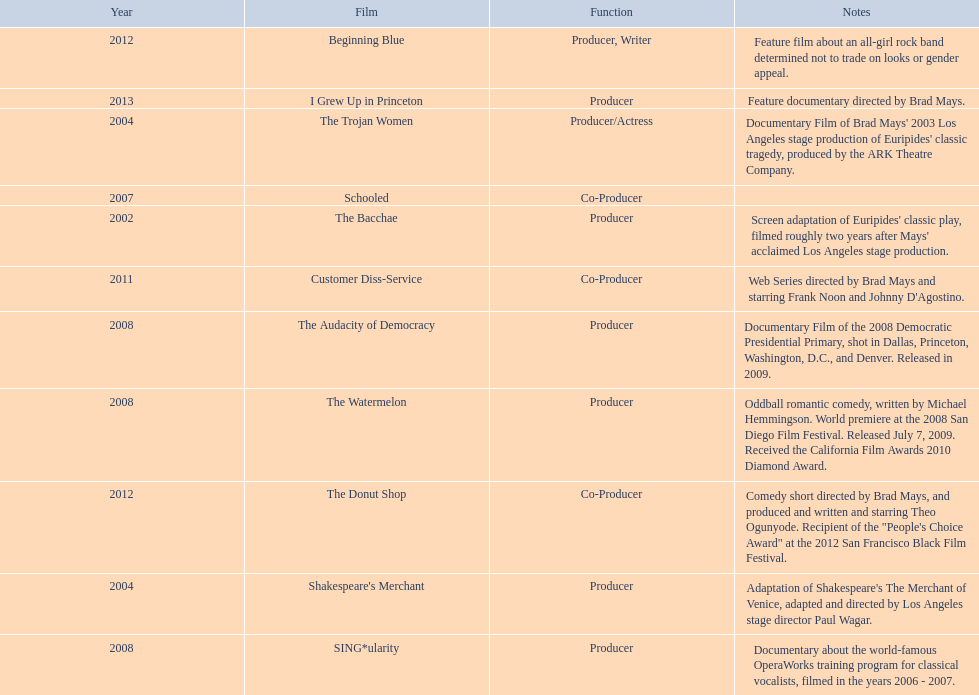Who was the first producer that made the film sing*ularity? Lorenda Starfelt. Can you parse all the data within this table? {'header': ['Year', 'Film', 'Function', 'Notes'], 'rows': [['2012', 'Beginning Blue', 'Producer, Writer', 'Feature film about an all-girl rock band determined not to trade on looks or gender appeal.'], ['2013', 'I Grew Up in Princeton', 'Producer', 'Feature documentary directed by Brad Mays.'], ['2004', 'The Trojan Women', 'Producer/Actress', "Documentary Film of Brad Mays' 2003 Los Angeles stage production of Euripides' classic tragedy, produced by the ARK Theatre Company."], ['2007', 'Schooled', 'Co-Producer', ''], ['2002', 'The Bacchae', 'Producer', "Screen adaptation of Euripides' classic play, filmed roughly two years after Mays' acclaimed Los Angeles stage production."], ['2011', 'Customer Diss-Service', 'Co-Producer', "Web Series directed by Brad Mays and starring Frank Noon and Johnny D'Agostino."], ['2008', 'The Audacity of Democracy', 'Producer', 'Documentary Film of the 2008 Democratic Presidential Primary, shot in Dallas, Princeton, Washington, D.C., and Denver. Released in 2009.'], ['2008', 'The Watermelon', 'Producer', 'Oddball romantic comedy, written by Michael Hemmingson. World premiere at the 2008 San Diego Film Festival. Released July 7, 2009. Received the California Film Awards 2010 Diamond Award.'], ['2012', 'The Donut Shop', 'Co-Producer', 'Comedy short directed by Brad Mays, and produced and written and starring Theo Ogunyode. Recipient of the "People\'s Choice Award" at the 2012 San Francisco Black Film Festival.'], ['2004', "Shakespeare's Merchant", 'Producer', "Adaptation of Shakespeare's The Merchant of Venice, adapted and directed by Los Angeles stage director Paul Wagar."], ['2008', 'SING*ularity', 'Producer', 'Documentary about the world-famous OperaWorks training program for classical vocalists, filmed in the years 2006 - 2007.']]} 